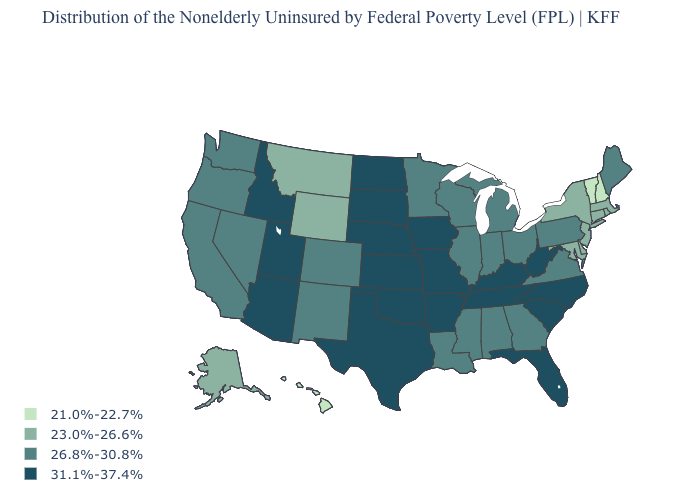What is the value of Indiana?
Keep it brief. 26.8%-30.8%. Name the states that have a value in the range 21.0%-22.7%?
Answer briefly. Hawaii, New Hampshire, Vermont. Among the states that border California , does Oregon have the lowest value?
Keep it brief. Yes. What is the value of Louisiana?
Be succinct. 26.8%-30.8%. What is the value of Illinois?
Short answer required. 26.8%-30.8%. What is the value of West Virginia?
Quick response, please. 31.1%-37.4%. Does the map have missing data?
Keep it brief. No. Does Michigan have a higher value than South Carolina?
Answer briefly. No. Does the map have missing data?
Be succinct. No. What is the highest value in the West ?
Keep it brief. 31.1%-37.4%. What is the lowest value in the USA?
Short answer required. 21.0%-22.7%. Among the states that border Illinois , does Indiana have the lowest value?
Answer briefly. Yes. Among the states that border Kansas , which have the highest value?
Concise answer only. Missouri, Nebraska, Oklahoma. What is the value of North Carolina?
Keep it brief. 31.1%-37.4%. Does Kentucky have the highest value in the South?
Be succinct. Yes. 